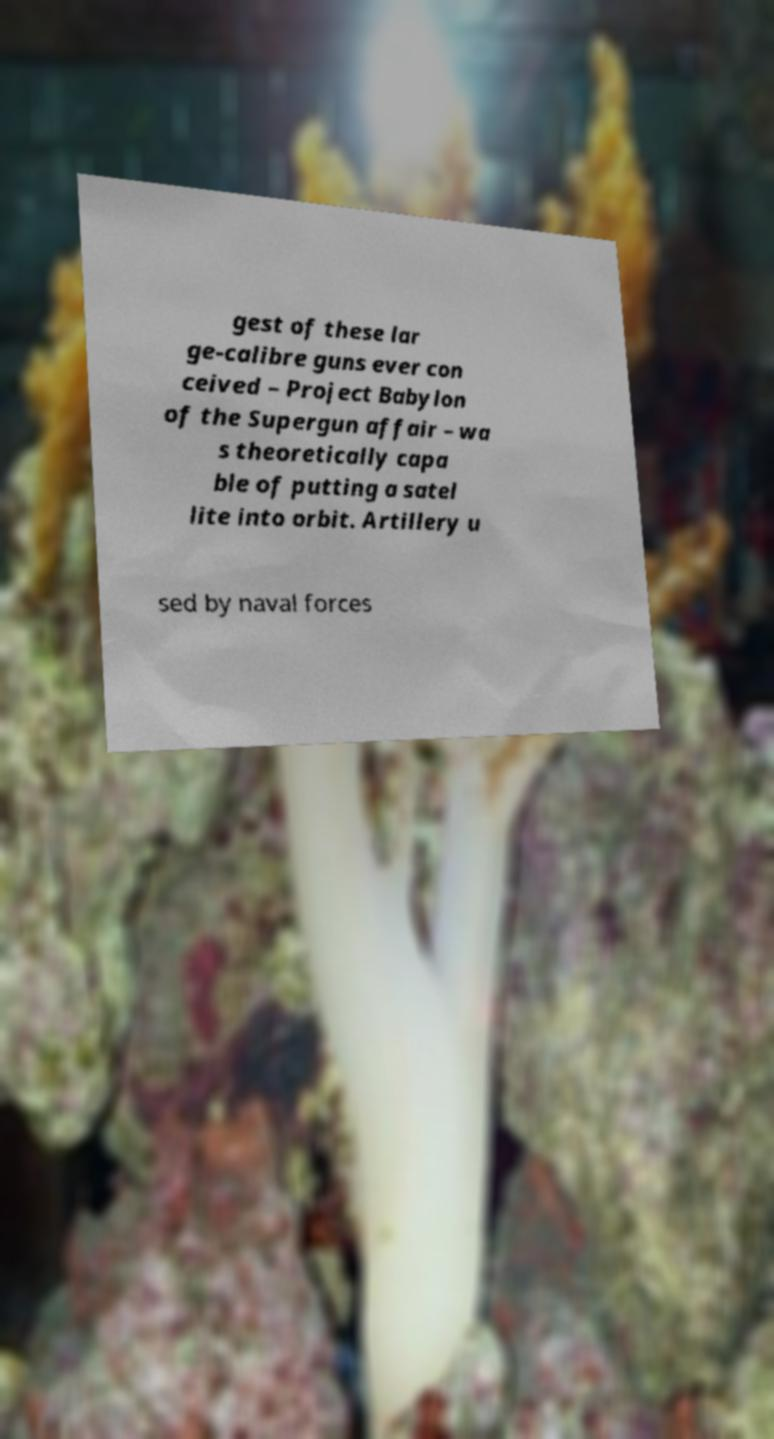Can you read and provide the text displayed in the image?This photo seems to have some interesting text. Can you extract and type it out for me? gest of these lar ge-calibre guns ever con ceived – Project Babylon of the Supergun affair – wa s theoretically capa ble of putting a satel lite into orbit. Artillery u sed by naval forces 